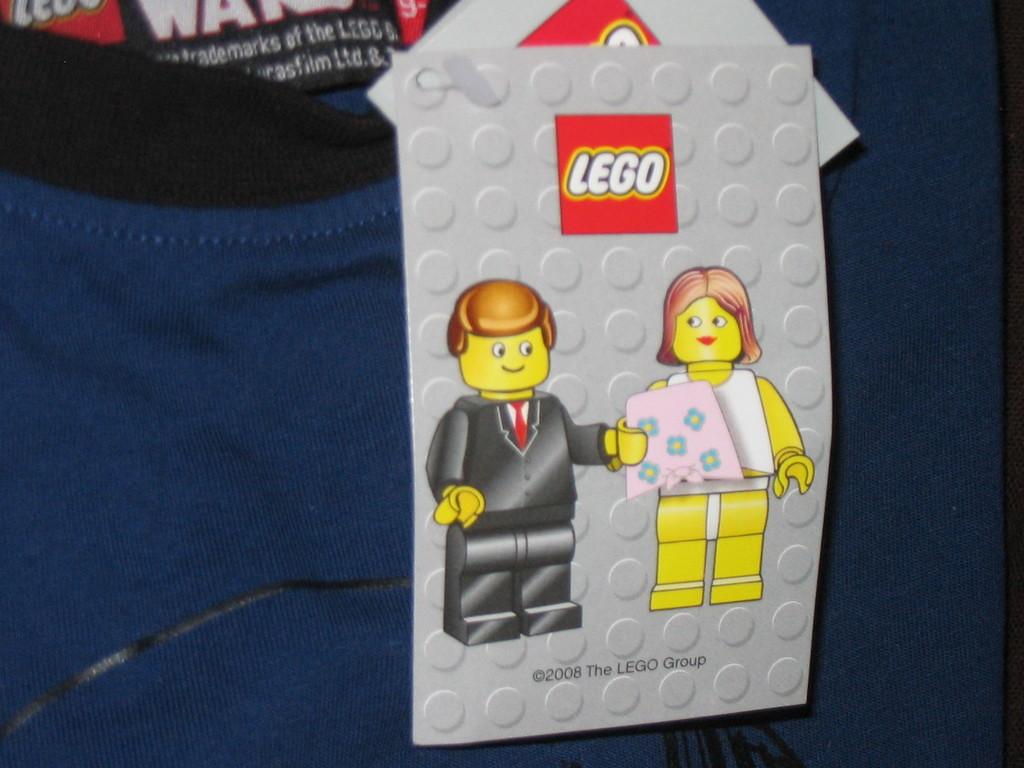What is the copyright year?
Your response must be concise. 2008. 